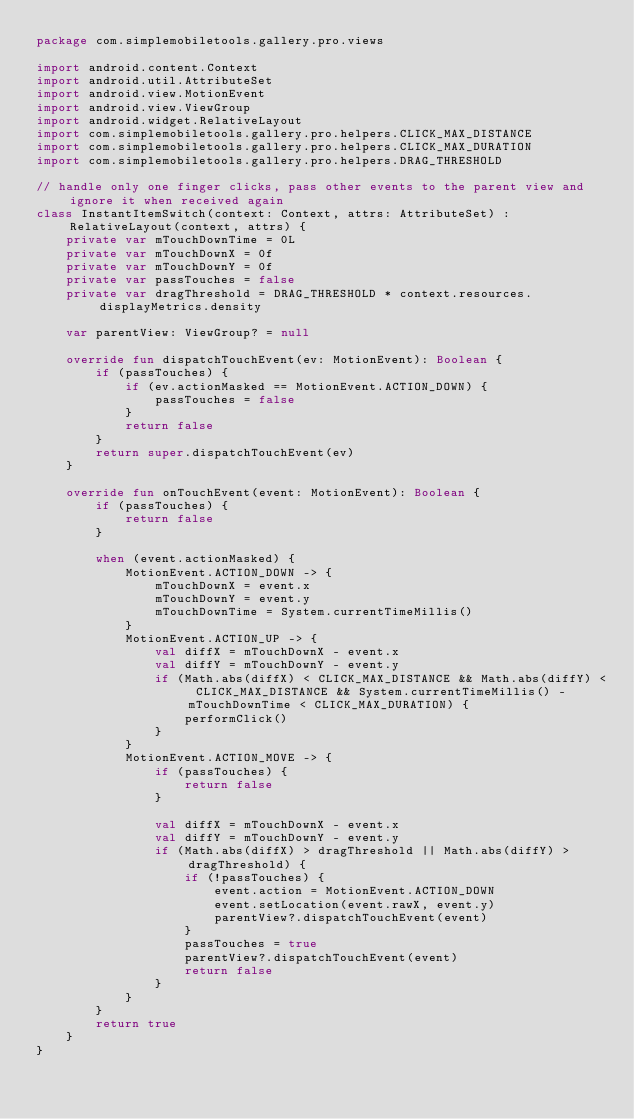Convert code to text. <code><loc_0><loc_0><loc_500><loc_500><_Kotlin_>package com.simplemobiletools.gallery.pro.views

import android.content.Context
import android.util.AttributeSet
import android.view.MotionEvent
import android.view.ViewGroup
import android.widget.RelativeLayout
import com.simplemobiletools.gallery.pro.helpers.CLICK_MAX_DISTANCE
import com.simplemobiletools.gallery.pro.helpers.CLICK_MAX_DURATION
import com.simplemobiletools.gallery.pro.helpers.DRAG_THRESHOLD

// handle only one finger clicks, pass other events to the parent view and ignore it when received again
class InstantItemSwitch(context: Context, attrs: AttributeSet) : RelativeLayout(context, attrs) {
    private var mTouchDownTime = 0L
    private var mTouchDownX = 0f
    private var mTouchDownY = 0f
    private var passTouches = false
    private var dragThreshold = DRAG_THRESHOLD * context.resources.displayMetrics.density

    var parentView: ViewGroup? = null

    override fun dispatchTouchEvent(ev: MotionEvent): Boolean {
        if (passTouches) {
            if (ev.actionMasked == MotionEvent.ACTION_DOWN) {
                passTouches = false
            }
            return false
        }
        return super.dispatchTouchEvent(ev)
    }

    override fun onTouchEvent(event: MotionEvent): Boolean {
        if (passTouches) {
            return false
        }

        when (event.actionMasked) {
            MotionEvent.ACTION_DOWN -> {
                mTouchDownX = event.x
                mTouchDownY = event.y
                mTouchDownTime = System.currentTimeMillis()
            }
            MotionEvent.ACTION_UP -> {
                val diffX = mTouchDownX - event.x
                val diffY = mTouchDownY - event.y
                if (Math.abs(diffX) < CLICK_MAX_DISTANCE && Math.abs(diffY) < CLICK_MAX_DISTANCE && System.currentTimeMillis() - mTouchDownTime < CLICK_MAX_DURATION) {
                    performClick()
                }
            }
            MotionEvent.ACTION_MOVE -> {
                if (passTouches) {
                    return false
                }

                val diffX = mTouchDownX - event.x
                val diffY = mTouchDownY - event.y
                if (Math.abs(diffX) > dragThreshold || Math.abs(diffY) > dragThreshold) {
                    if (!passTouches) {
                        event.action = MotionEvent.ACTION_DOWN
                        event.setLocation(event.rawX, event.y)
                        parentView?.dispatchTouchEvent(event)
                    }
                    passTouches = true
                    parentView?.dispatchTouchEvent(event)
                    return false
                }
            }
        }
        return true
    }
}
</code> 